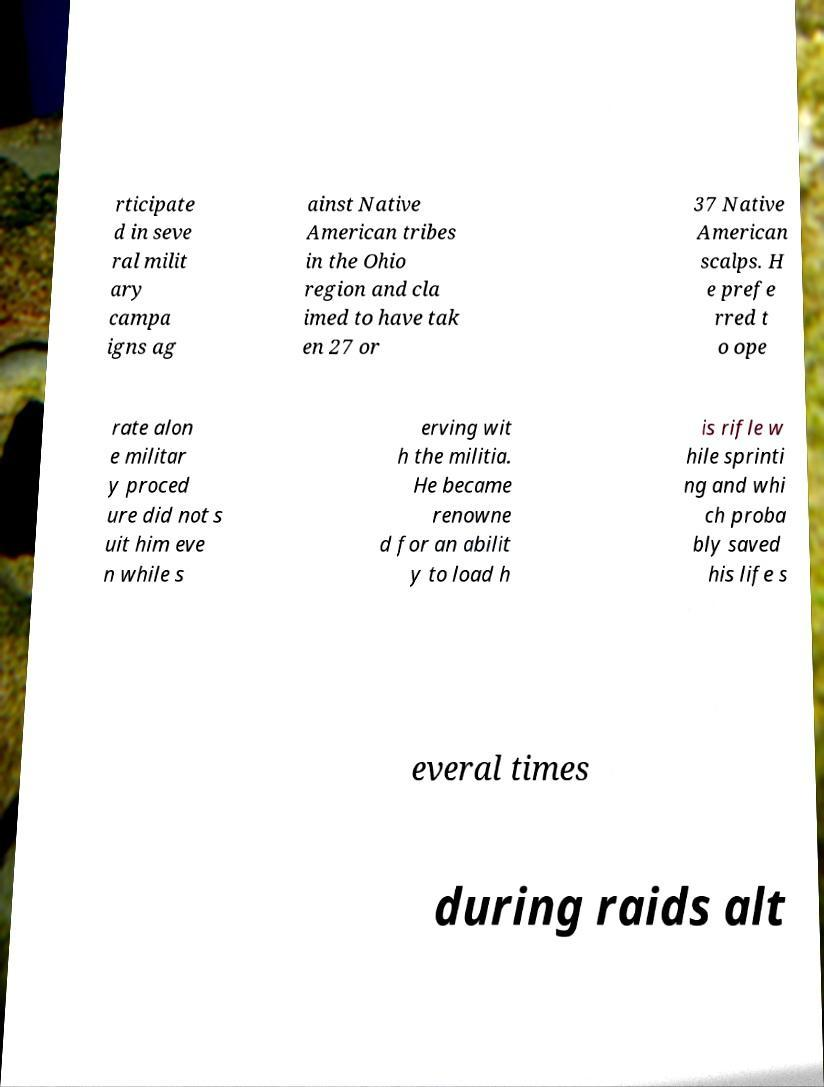What messages or text are displayed in this image? I need them in a readable, typed format. rticipate d in seve ral milit ary campa igns ag ainst Native American tribes in the Ohio region and cla imed to have tak en 27 or 37 Native American scalps. H e prefe rred t o ope rate alon e militar y proced ure did not s uit him eve n while s erving wit h the militia. He became renowne d for an abilit y to load h is rifle w hile sprinti ng and whi ch proba bly saved his life s everal times during raids alt 